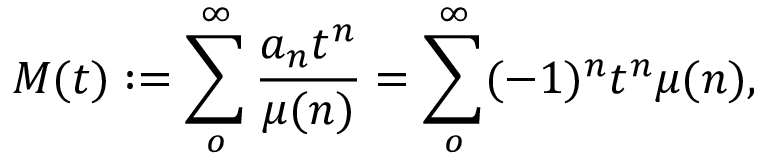<formula> <loc_0><loc_0><loc_500><loc_500>M ( t ) \colon = \sum _ { o } ^ { \infty } \frac { a _ { n } t ^ { n } } { \mu ( n ) } = \sum _ { o } ^ { \infty } ( - 1 ) ^ { n } t ^ { n } \mu ( n ) ,</formula> 